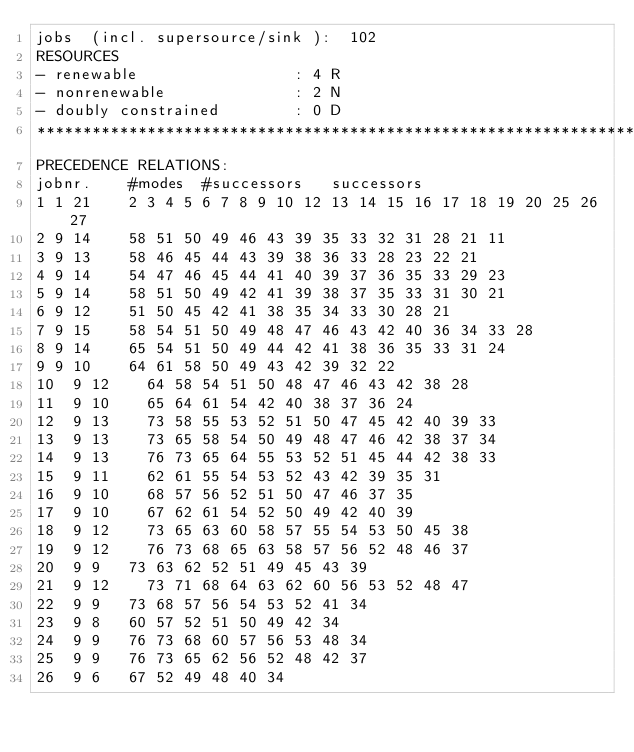<code> <loc_0><loc_0><loc_500><loc_500><_ObjectiveC_>jobs  (incl. supersource/sink ):	102
RESOURCES
- renewable                 : 4 R
- nonrenewable              : 2 N
- doubly constrained        : 0 D
************************************************************************
PRECEDENCE RELATIONS:
jobnr.    #modes  #successors   successors
1	1	21		2 3 4 5 6 7 8 9 10 12 13 14 15 16 17 18 19 20 25 26 27 
2	9	14		58 51 50 49 46 43 39 35 33 32 31 28 21 11 
3	9	13		58 46 45 44 43 39 38 36 33 28 23 22 21 
4	9	14		54 47 46 45 44 41 40 39 37 36 35 33 29 23 
5	9	14		58 51 50 49 42 41 39 38 37 35 33 31 30 21 
6	9	12		51 50 45 42 41 38 35 34 33 30 28 21 
7	9	15		58 54 51 50 49 48 47 46 43 42 40 36 34 33 28 
8	9	14		65 54 51 50 49 44 42 41 38 36 35 33 31 24 
9	9	10		64 61 58 50 49 43 42 39 32 22 
10	9	12		64 58 54 51 50 48 47 46 43 42 38 28 
11	9	10		65 64 61 54 42 40 38 37 36 24 
12	9	13		73 58 55 53 52 51 50 47 45 42 40 39 33 
13	9	13		73 65 58 54 50 49 48 47 46 42 38 37 34 
14	9	13		76 73 65 64 55 53 52 51 45 44 42 38 33 
15	9	11		62 61 55 54 53 52 43 42 39 35 31 
16	9	10		68 57 56 52 51 50 47 46 37 35 
17	9	10		67 62 61 54 52 50 49 42 40 39 
18	9	12		73 65 63 60 58 57 55 54 53 50 45 38 
19	9	12		76 73 68 65 63 58 57 56 52 48 46 37 
20	9	9		73 63 62 52 51 49 45 43 39 
21	9	12		73 71 68 64 63 62 60 56 53 52 48 47 
22	9	9		73 68 57 56 54 53 52 41 34 
23	9	8		60 57 52 51 50 49 42 34 
24	9	9		76 73 68 60 57 56 53 48 34 
25	9	9		76 73 65 62 56 52 48 42 37 
26	9	6		67 52 49 48 40 34 </code> 